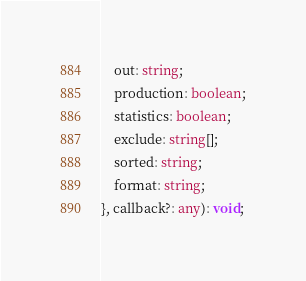<code> <loc_0><loc_0><loc_500><loc_500><_TypeScript_>    out: string;
    production: boolean;
    statistics: boolean;
    exclude: string[];
    sorted: string;
    format: string;
}, callback?: any): void;
</code> 